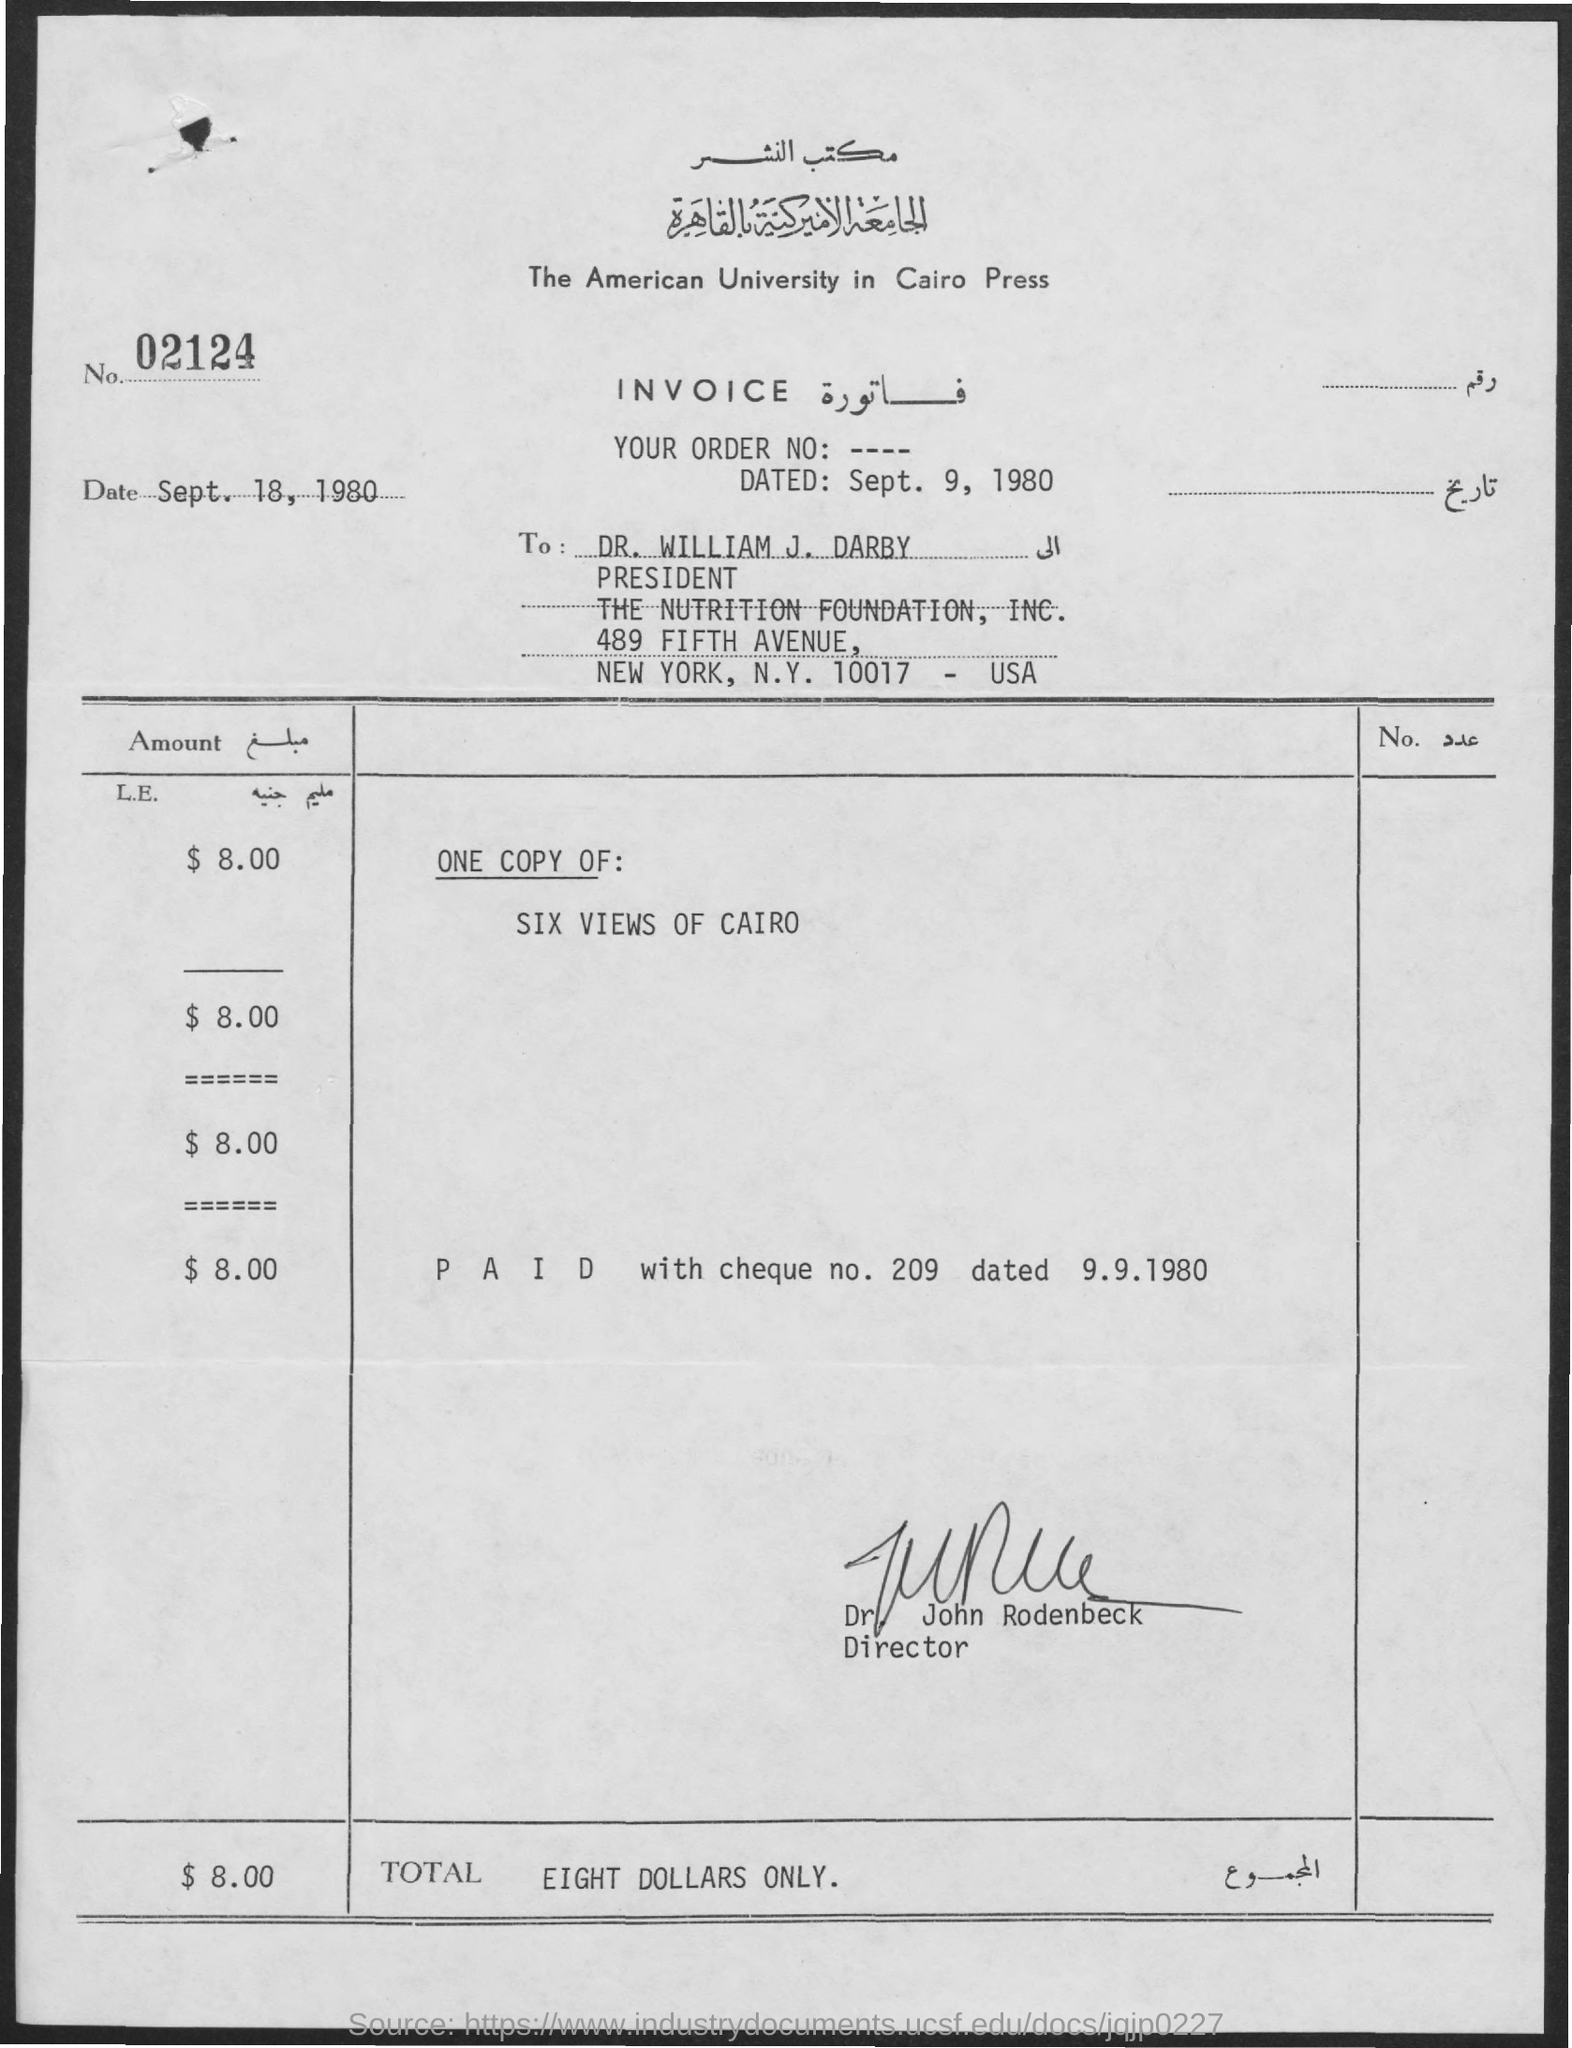Point out several critical features in this image. The cheque number is 209," the speaker declared. The order date is September 9, 1980. The total is eight dollars and only eight dollars. The name of the director is John Rodenbeck. 